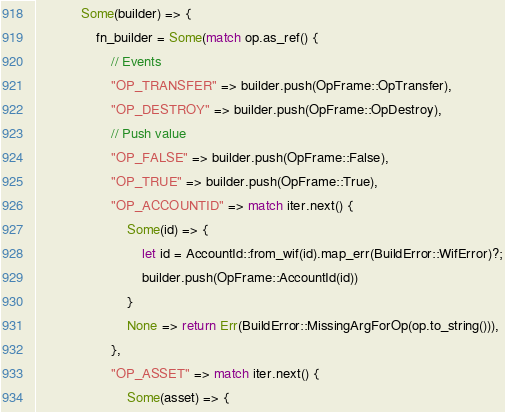Convert code to text. <code><loc_0><loc_0><loc_500><loc_500><_Rust_>            Some(builder) => {
                fn_builder = Some(match op.as_ref() {
                    // Events
                    "OP_TRANSFER" => builder.push(OpFrame::OpTransfer),
                    "OP_DESTROY" => builder.push(OpFrame::OpDestroy),
                    // Push value
                    "OP_FALSE" => builder.push(OpFrame::False),
                    "OP_TRUE" => builder.push(OpFrame::True),
                    "OP_ACCOUNTID" => match iter.next() {
                        Some(id) => {
                            let id = AccountId::from_wif(id).map_err(BuildError::WifError)?;
                            builder.push(OpFrame::AccountId(id))
                        }
                        None => return Err(BuildError::MissingArgForOp(op.to_string())),
                    },
                    "OP_ASSET" => match iter.next() {
                        Some(asset) => {</code> 